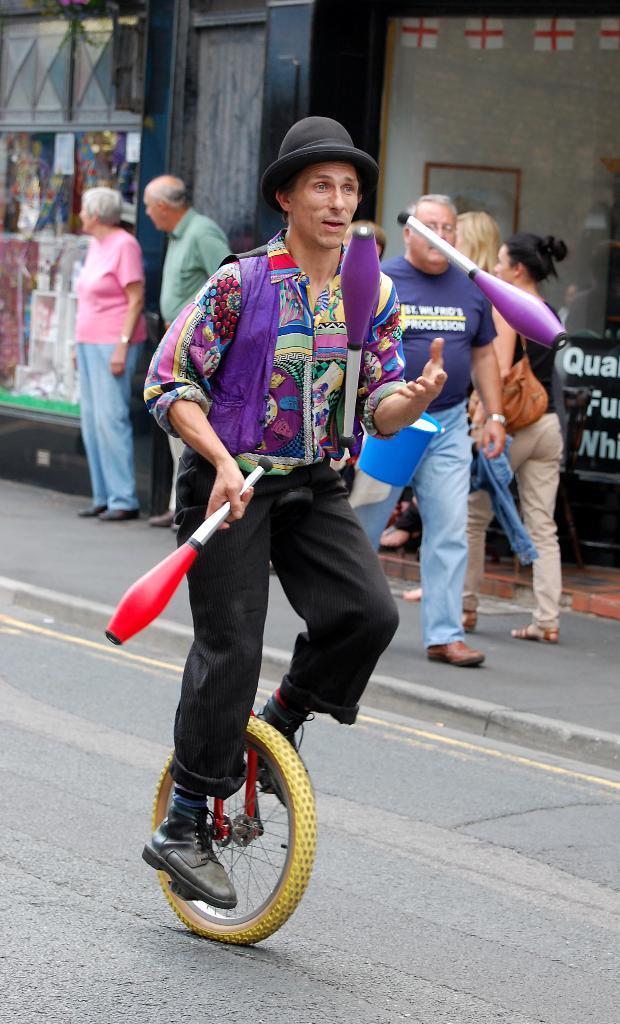Please provide a concise description of this image. In this image a person is riding a cycle. He is juggling. In the background there are few people walking on the sidewalk. In the back there are buildings. 